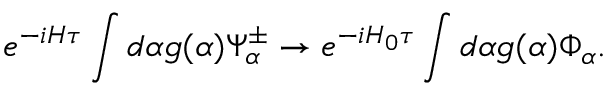Convert formula to latex. <formula><loc_0><loc_0><loc_500><loc_500>e ^ { - i H \tau } \int d \alpha g ( \alpha ) \Psi _ { \alpha } ^ { \pm } \rightarrow e ^ { - i H _ { 0 } \tau } \int d \alpha g ( \alpha ) \Phi _ { \alpha } .</formula> 